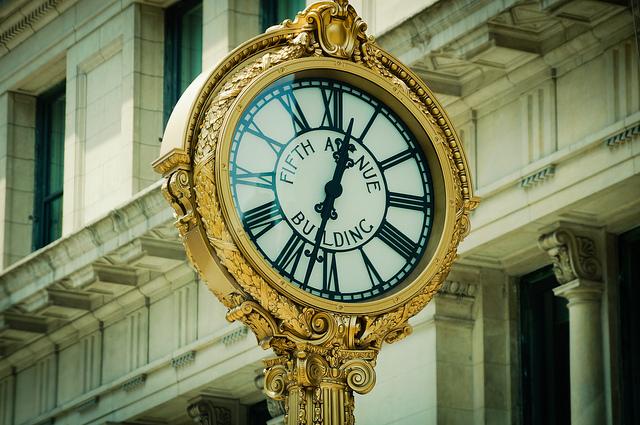How many numbers are on this clock?
Be succinct. 12. What time does the clock say?
Concise answer only. 12:33. Is that the correct time?
Short answer required. Yes. 